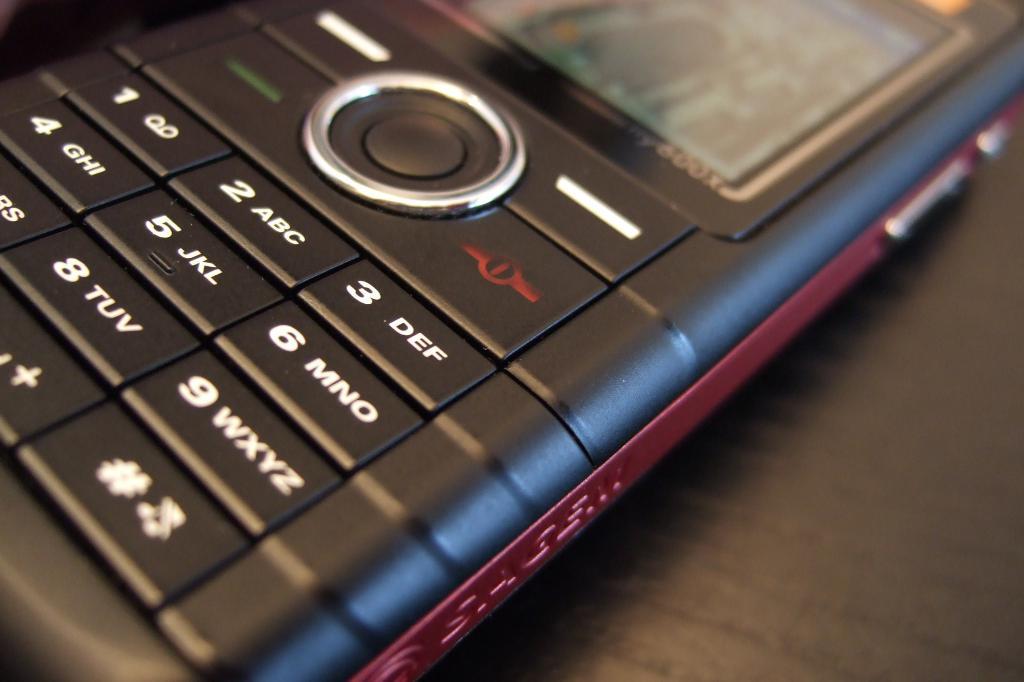What letters does the 2 key correspond to?
Keep it short and to the point. Abc. 